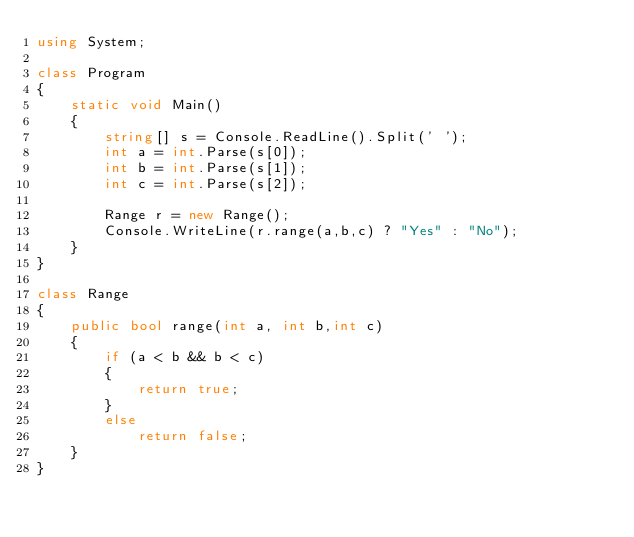<code> <loc_0><loc_0><loc_500><loc_500><_C#_>using System;

class Program
{
    static void Main()
    {
        string[] s = Console.ReadLine().Split(' ');
        int a = int.Parse(s[0]);
        int b = int.Parse(s[1]);
        int c = int.Parse(s[2]);

        Range r = new Range();
        Console.WriteLine(r.range(a,b,c) ? "Yes" : "No");
    }
}

class Range
{
    public bool range(int a, int b,int c)
    {
        if (a < b && b < c)
        {
            return true;
        }
        else
            return false;
    }
}</code> 